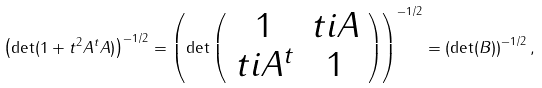Convert formula to latex. <formula><loc_0><loc_0><loc_500><loc_500>\left ( \det ( 1 + t ^ { 2 } A ^ { t } A ) \right ) ^ { - 1 / 2 } = \left ( \det \left ( \begin{array} { c c } 1 & t i A \\ t i A ^ { t } & 1 \end{array} \right ) \right ) ^ { - 1 / 2 } = \left ( \det ( B ) \right ) ^ { - 1 / 2 } ,</formula> 